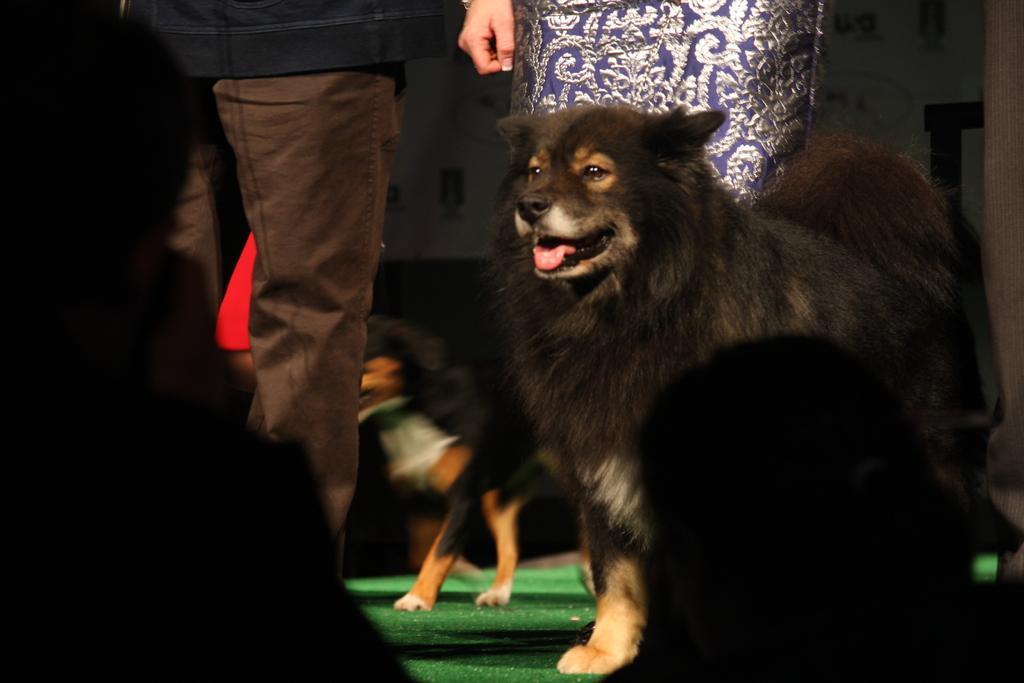Can you describe this image briefly? In the picture there are dogs present, beside the dogs there are people present. 